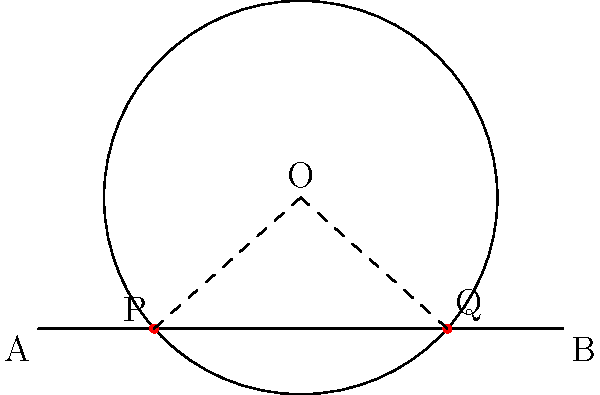In a La Liga match, a circular sprinkler system with radius 3 meters is partially overlapping the sideline of the football field. If the distance between the two intersection points of the circle and the sideline is 6 meters, what is the perpendicular distance from the center of the circle to the sideline? Let's approach this step-by-step:

1) Let O be the center of the circle, and P and Q be the intersection points of the circle and the sideline.

2) The line PQ is a chord of the circle, and its length is given as 6 meters.

3) Let's draw the perpendicular from O to PQ. This line will bisect PQ at point M.

4) Now we have a right-angled triangle OMP.

5) In this triangle:
   - OM is the distance we're looking for
   - OP is the radius of the circle (3 meters)
   - PM is half of PQ (3 meters)

6) We can use the Pythagorean theorem:

   $$OM^2 + PM^2 = OP^2$$

7) Substituting the known values:

   $$OM^2 + 3^2 = 3^2$$

8) Simplifying:

   $$OM^2 = 3^2 - 3^2 = 9 - 9 = 0$$

9) Taking the square root of both sides:

   $$OM = \sqrt{0} = 0$$

Therefore, the center of the circle is exactly on the sideline.
Answer: 0 meters 